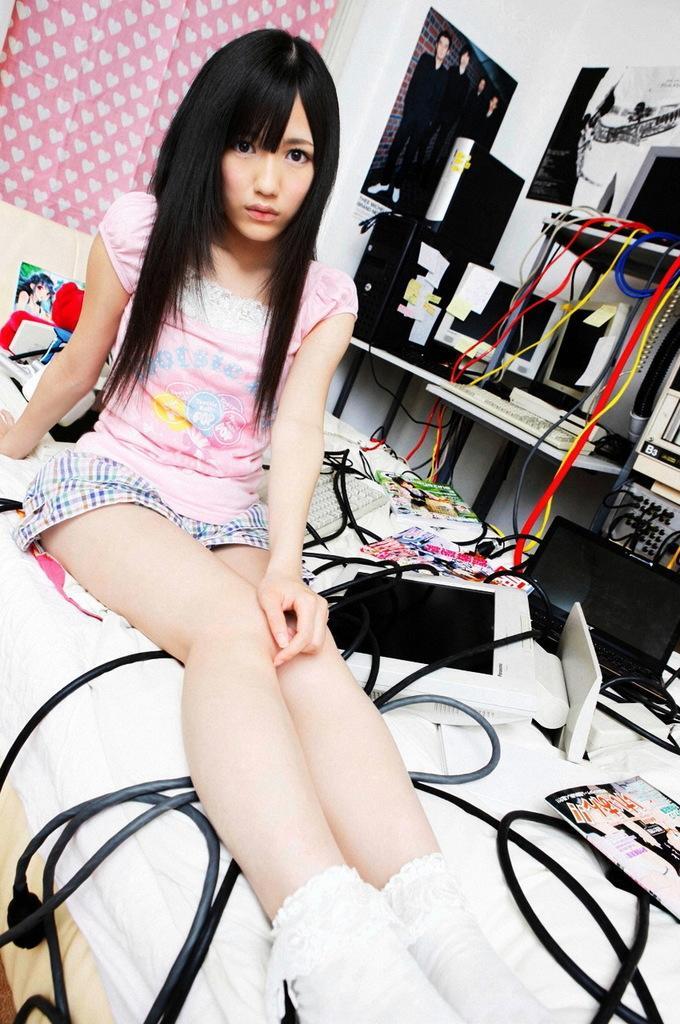Please provide a concise description of this image. In this image we can see a girl is sitting on bed. She is wearing pink color t-shirt. Beside her laptop, monitors, wires and books are there. Background of the image white color wall is there. On wall one poster is pasted. Right side of the image monitors are there. 